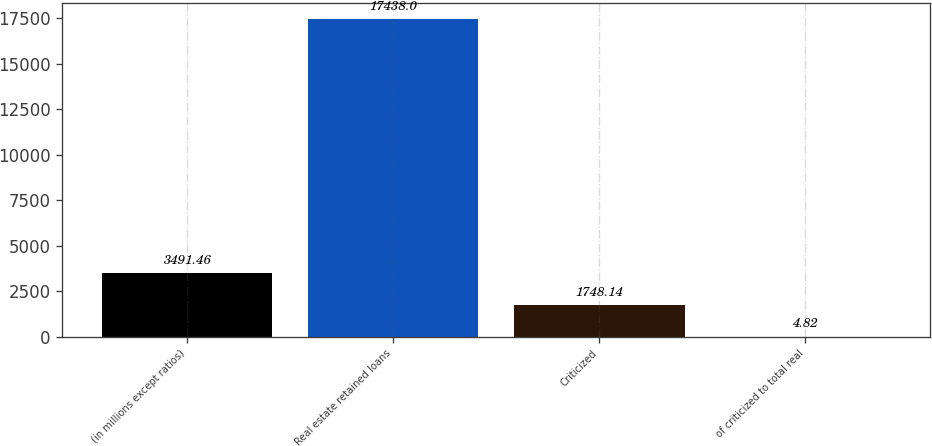Convert chart to OTSL. <chart><loc_0><loc_0><loc_500><loc_500><bar_chart><fcel>(in millions except ratios)<fcel>Real estate retained loans<fcel>Criticized<fcel>of criticized to total real<nl><fcel>3491.46<fcel>17438<fcel>1748.14<fcel>4.82<nl></chart> 